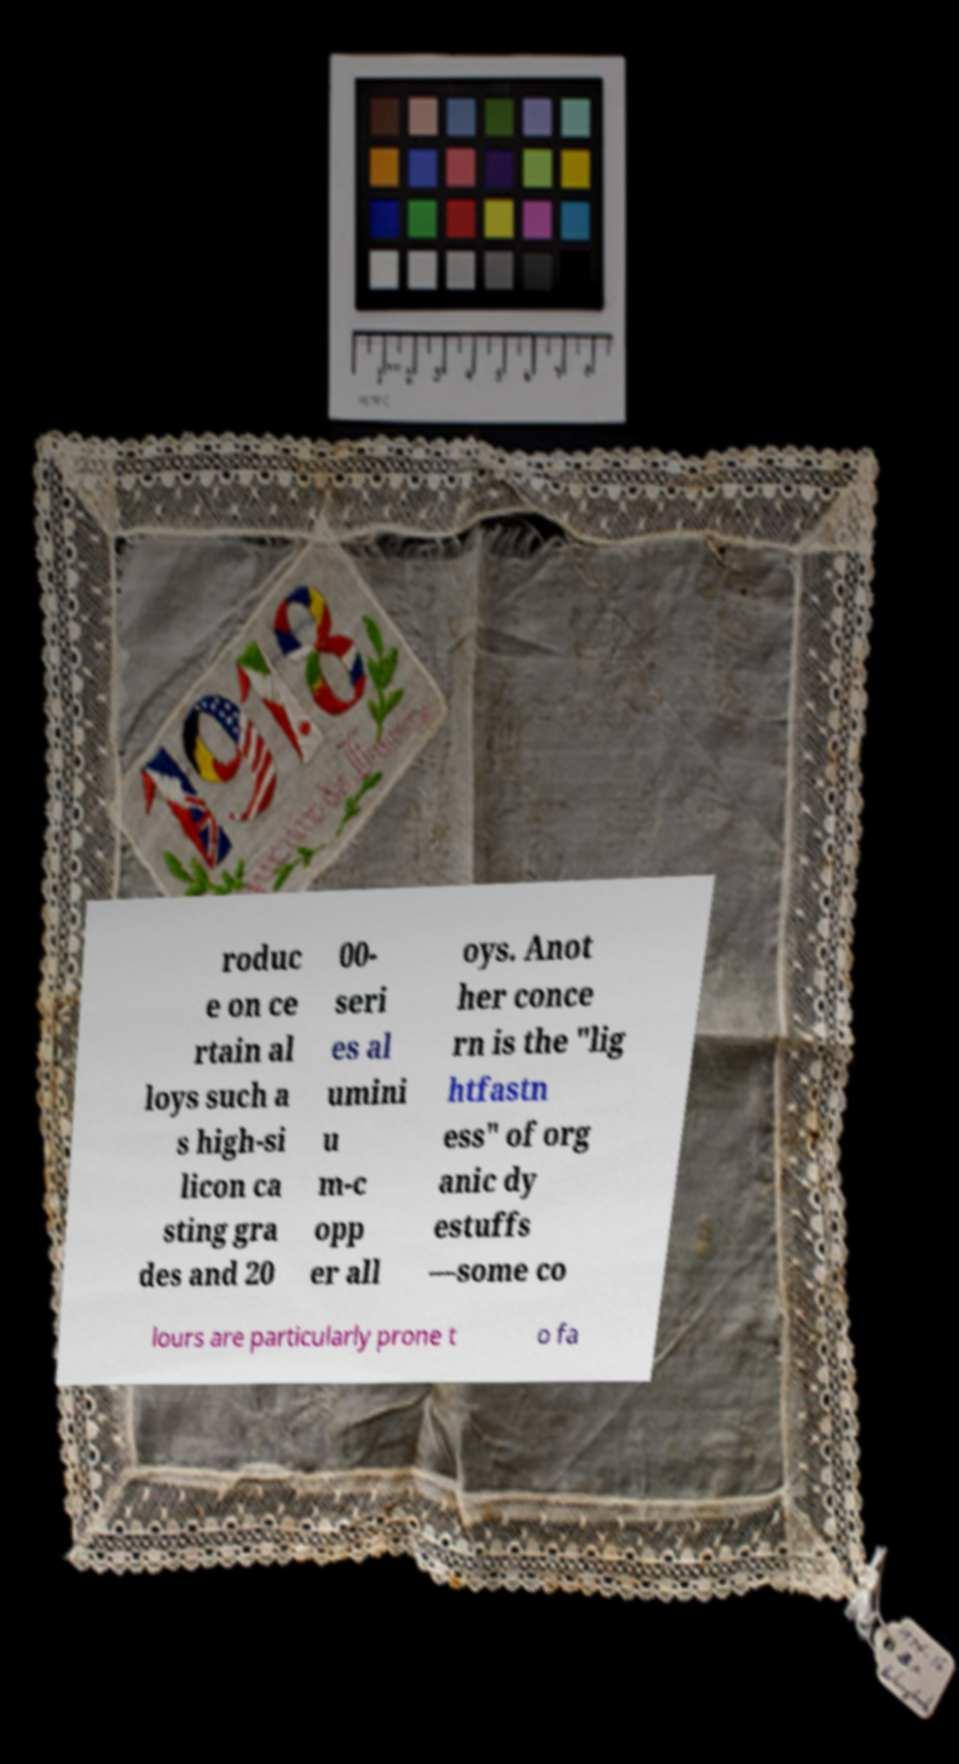Can you accurately transcribe the text from the provided image for me? roduc e on ce rtain al loys such a s high-si licon ca sting gra des and 20 00- seri es al umini u m-c opp er all oys. Anot her conce rn is the "lig htfastn ess" of org anic dy estuffs —some co lours are particularly prone t o fa 